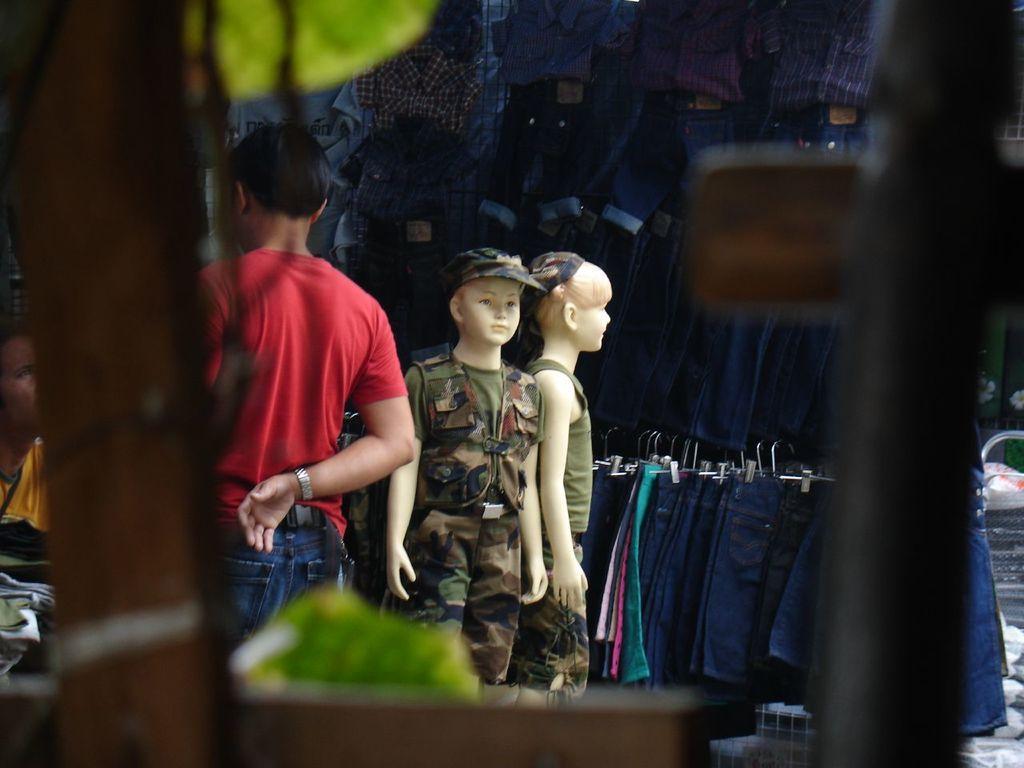In one or two sentences, can you explain what this image depicts? In this image I can see two mannequins wearing military dress. I can see few people and few blue color dress around. 